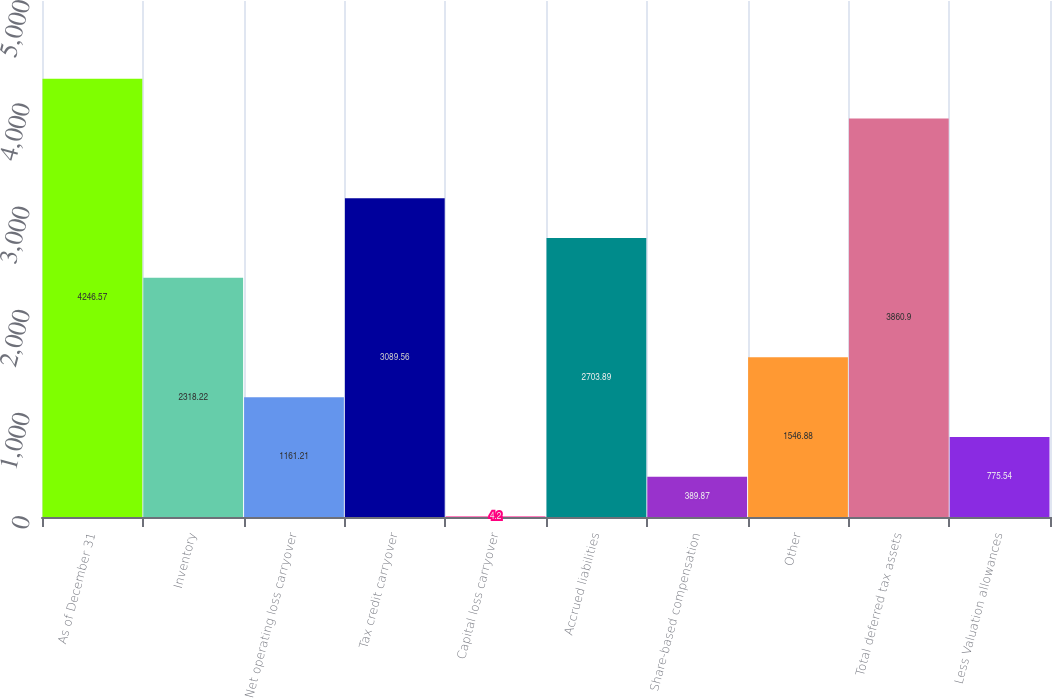<chart> <loc_0><loc_0><loc_500><loc_500><bar_chart><fcel>As of December 31<fcel>Inventory<fcel>Net operating loss carryover<fcel>Tax credit carryover<fcel>Capital loss carryover<fcel>Accrued liabilities<fcel>Share-based compensation<fcel>Other<fcel>Total deferred tax assets<fcel>Less Valuation allowances<nl><fcel>4246.57<fcel>2318.22<fcel>1161.21<fcel>3089.56<fcel>4.2<fcel>2703.89<fcel>389.87<fcel>1546.88<fcel>3860.9<fcel>775.54<nl></chart> 